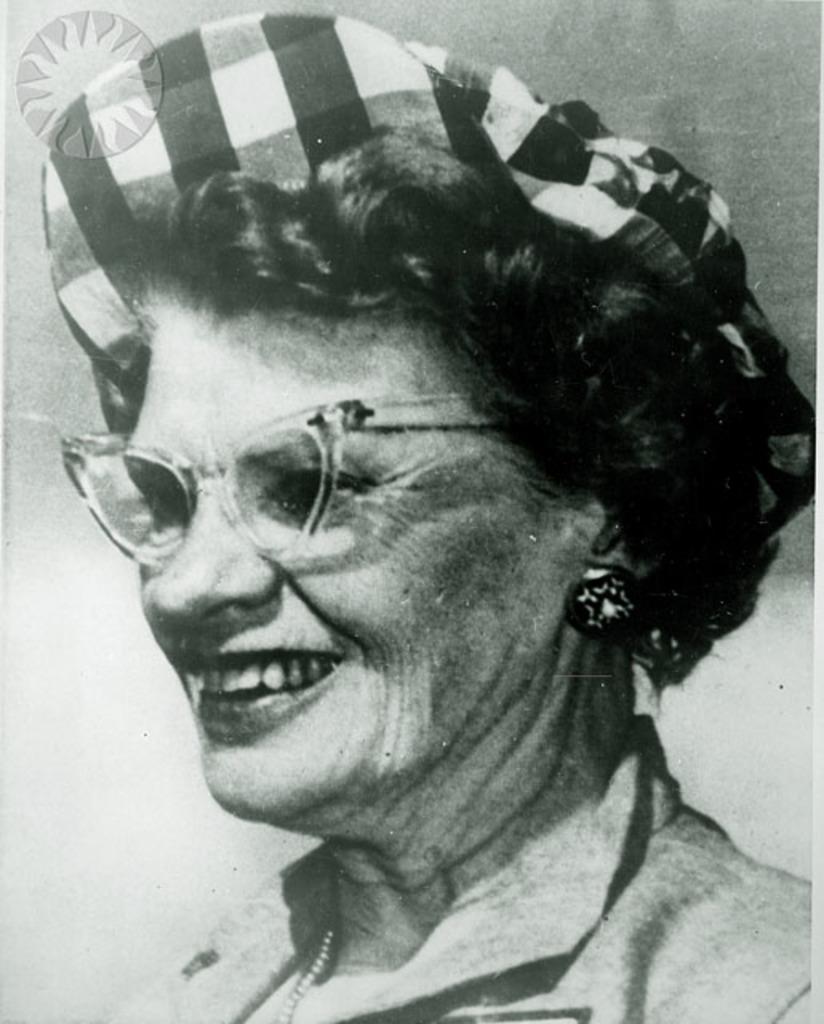Could you give a brief overview of what you see in this image? This is a black and white picture of a woman. This woman looking at other side. She smile beautiful. She wore spectacles. She wore black and white checkered cap. 